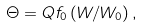<formula> <loc_0><loc_0><loc_500><loc_500>\Theta = Q f _ { 0 } \left ( W / W _ { 0 } \right ) ,</formula> 